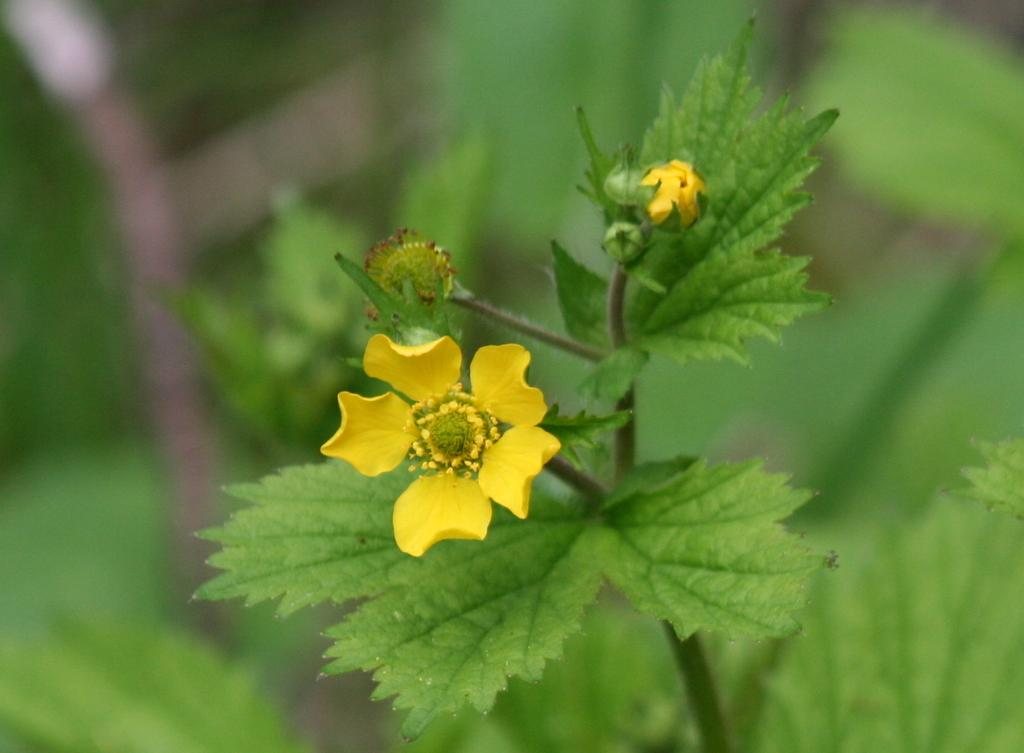What type of vegetation can be seen in the image? There are leaves and flowers in the image. What color are the flowers in the image? The flowers in the image are yellow in color. How is the background of the image depicted? The background of the image is blurred. Can you tell me how many pencils are visible in the image? There are no pencils present in the image. What type of scarf is wrapped around the leaves in the image? There is no scarf present in the image; it only features leaves and flowers. 